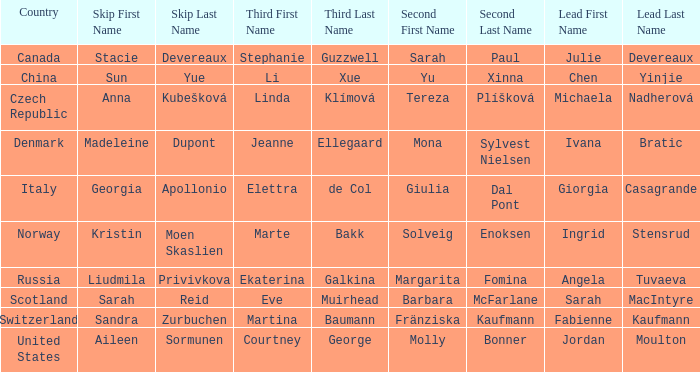What skip features denmark as the nation? Madeleine Dupont. 